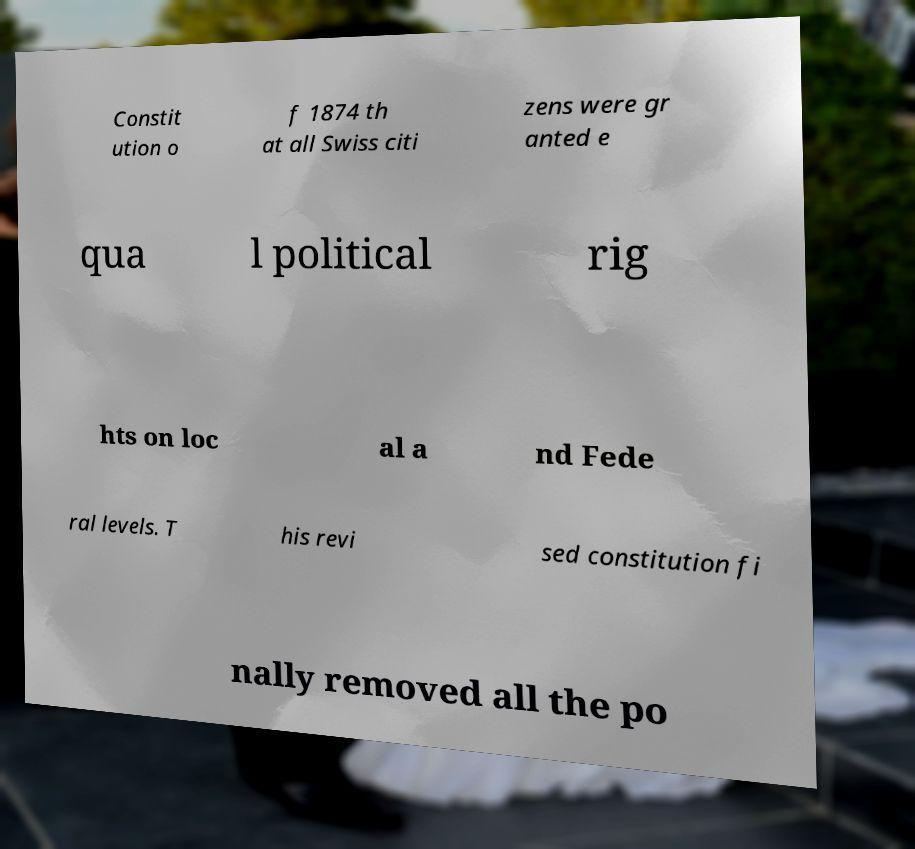Please read and relay the text visible in this image. What does it say? Constit ution o f 1874 th at all Swiss citi zens were gr anted e qua l political rig hts on loc al a nd Fede ral levels. T his revi sed constitution fi nally removed all the po 